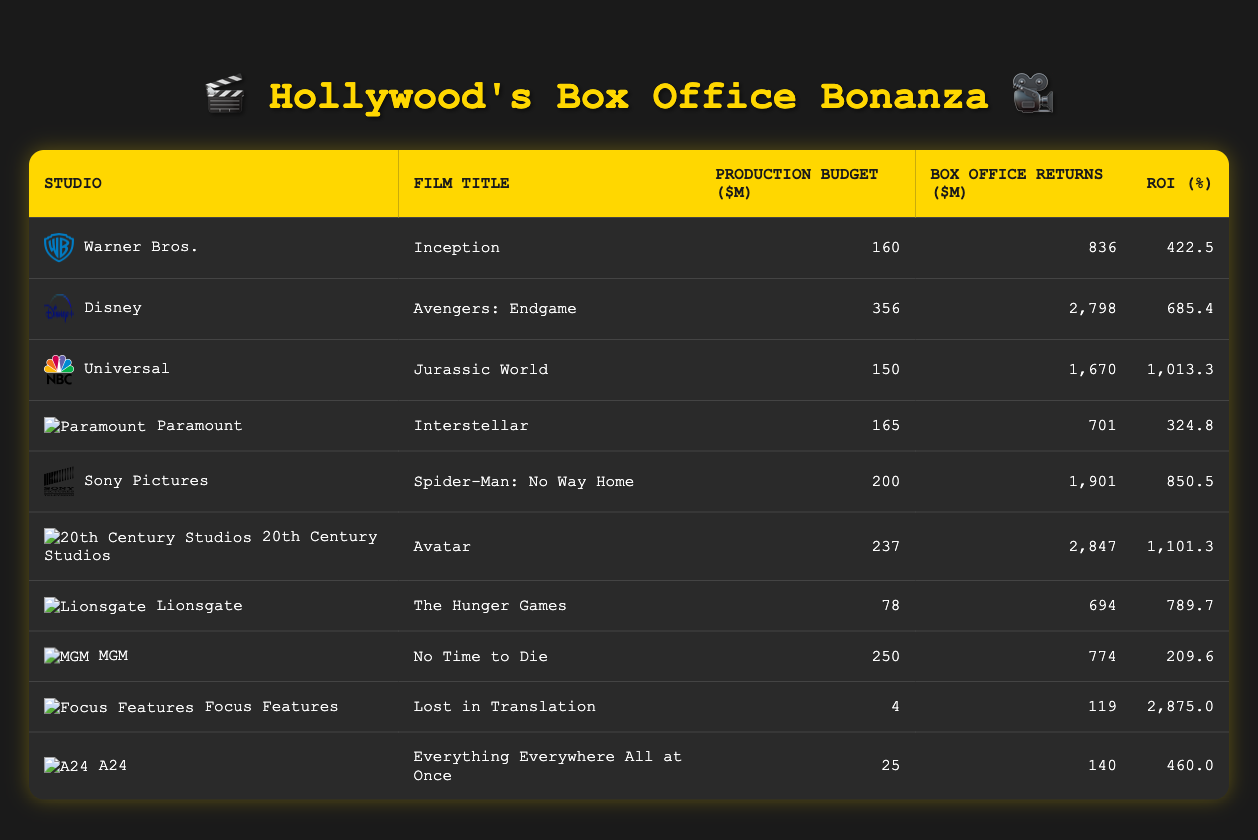What is the production budget of "Avatar"? The table shows that "Avatar" has a production budget of 237 million dollars listed in the "Production Budget ($M)" column next to "20th Century Studios".
Answer: 237 Which film had the highest box office return? The film with the highest box office return is "Avengers: Endgame" with 2798 million dollars, which can be found by comparing the values in the "Box Office Returns ($M)" column.
Answer: 2798 What is the ROI percentage for "Lost in Translation"? The table lists the ROI percentage for "Lost in Translation" as 2875.0%. This is found in the "ROI (%)" column next to the film title under "Focus Features".
Answer: 2875.0 Which studio had the lowest ROI, and what was it? To find the studio with the lowest ROI, compare the ROI percentages in the last column. "MGM" has the lowest ROI of 209.6%, as displayed in the "ROI (%)" column.
Answer: MGM, 209.6 What is the average production budget for the films listed? First, add up all the production budgets: 160 + 356 + 150 + 165 + 200 + 237 + 78 + 250 + 4 + 25 = 1625 million dollars. Then divide by the number of films (10): 1625 / 10 = 162.5 million dollars.
Answer: 162.5 Did "Spider-Man: No Way Home" have a better ROI than "Jurassic World"? Comparing their ROIs, "Spider-Man: No Way Home" has an ROI of 850.5%, while "Jurassic World" has an ROI of 1013.3%. Since 850.5% is less than 1013.3%, the statement is false.
Answer: No What is the overall sum of the box office returns for all films? To find the overall sum, add the box office returns: 836 + 2798 + 1670 + 701 + 1901 + 2847 + 694 + 774 + 119 + 140 = 11690 million dollars.
Answer: 11690 Which studio's film had the smallest production budget? The studio with the smallest production budget is Focus Features with "Lost in Translation", which had a budget of 4 million dollars, seen in the "Production Budget ($M)" column.
Answer: Focus Features, 4 